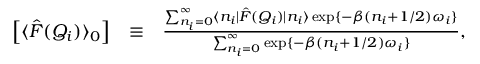<formula> <loc_0><loc_0><loc_500><loc_500>\begin{array} { r l r } { \left [ \langle \hat { F } ( Q _ { i } ) \rangle _ { 0 } \right ] } & { \equiv } & { \frac { \sum _ { n _ { i } = 0 } ^ { \infty } \langle n _ { i } | \hat { F } ( Q _ { i } ) | n _ { i } \rangle \exp \{ - \beta ( n _ { i } + 1 / 2 ) \omega _ { i } \} } { \sum _ { n _ { i } = 0 } ^ { \infty } \exp \{ - \beta ( n _ { i } + 1 / 2 ) \omega _ { i } \} } , } \end{array}</formula> 